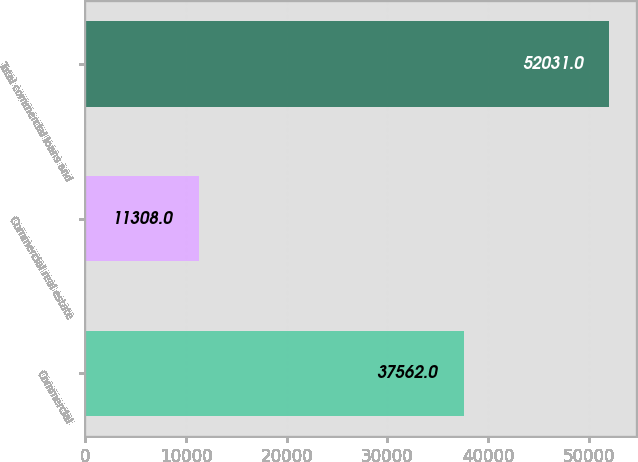Convert chart. <chart><loc_0><loc_0><loc_500><loc_500><bar_chart><fcel>Commercial<fcel>Commercial real estate<fcel>Total commercial loans and<nl><fcel>37562<fcel>11308<fcel>52031<nl></chart> 